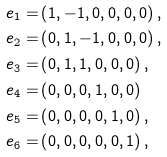Convert formula to latex. <formula><loc_0><loc_0><loc_500><loc_500>e _ { 1 } = & \left ( 1 , - 1 , 0 , 0 , 0 , 0 \right ) , \\ e _ { 2 } = & \left ( 0 , 1 , - 1 , 0 , 0 , 0 \right ) , \\ e _ { 3 } = & \left ( 0 , 1 , 1 , 0 , 0 , 0 \right ) , \\ e _ { 4 } = & \left ( 0 , 0 , 0 , 1 , 0 , 0 \right ) \\ e _ { 5 } = & \left ( 0 , 0 , 0 , 0 , 1 , 0 \right ) , \\ e _ { 6 } = & \left ( 0 , 0 , 0 , 0 , 0 , 1 \right ) ,</formula> 